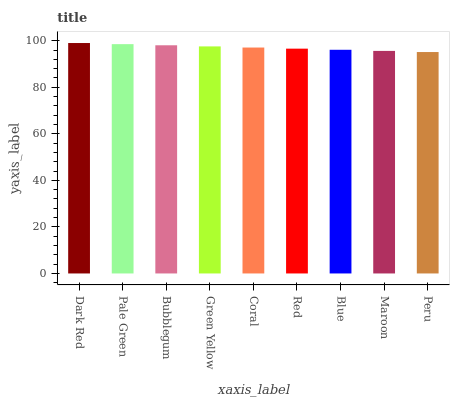Is Peru the minimum?
Answer yes or no. Yes. Is Dark Red the maximum?
Answer yes or no. Yes. Is Pale Green the minimum?
Answer yes or no. No. Is Pale Green the maximum?
Answer yes or no. No. Is Dark Red greater than Pale Green?
Answer yes or no. Yes. Is Pale Green less than Dark Red?
Answer yes or no. Yes. Is Pale Green greater than Dark Red?
Answer yes or no. No. Is Dark Red less than Pale Green?
Answer yes or no. No. Is Coral the high median?
Answer yes or no. Yes. Is Coral the low median?
Answer yes or no. Yes. Is Pale Green the high median?
Answer yes or no. No. Is Red the low median?
Answer yes or no. No. 